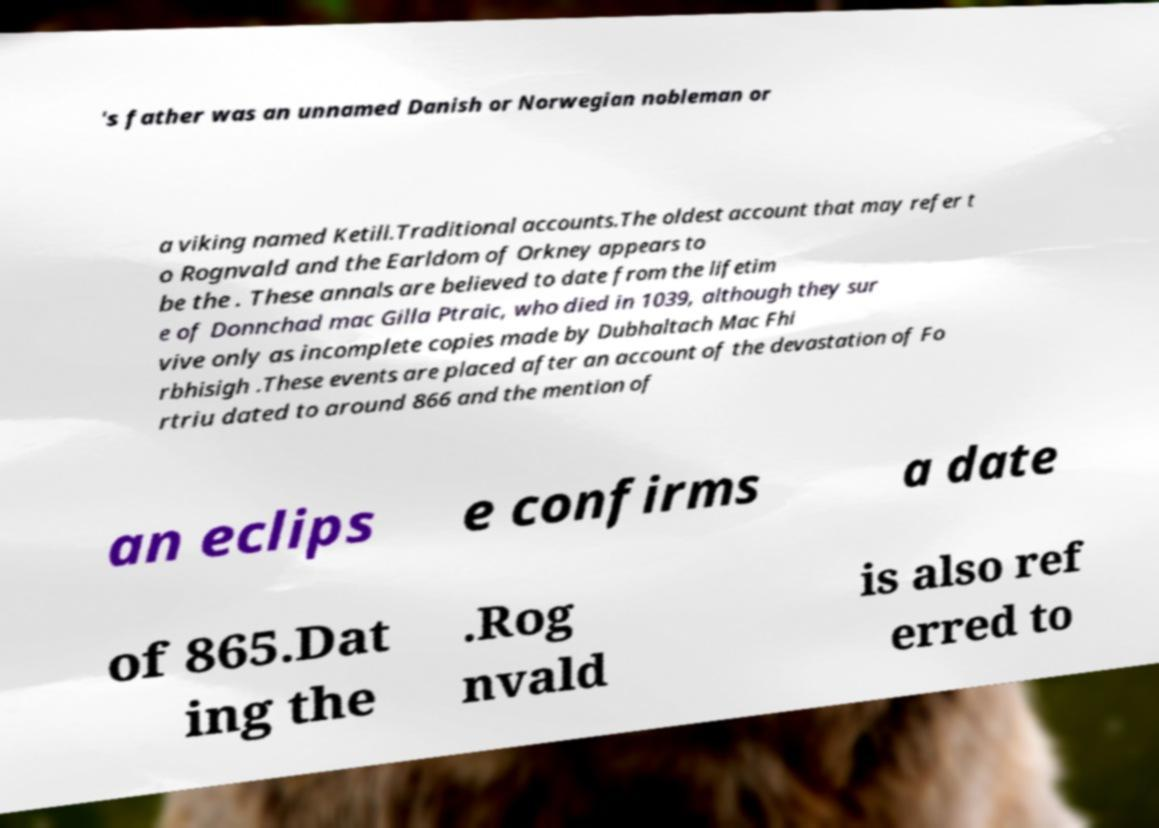Please identify and transcribe the text found in this image. 's father was an unnamed Danish or Norwegian nobleman or a viking named Ketill.Traditional accounts.The oldest account that may refer t o Rognvald and the Earldom of Orkney appears to be the . These annals are believed to date from the lifetim e of Donnchad mac Gilla Ptraic, who died in 1039, although they sur vive only as incomplete copies made by Dubhaltach Mac Fhi rbhisigh .These events are placed after an account of the devastation of Fo rtriu dated to around 866 and the mention of an eclips e confirms a date of 865.Dat ing the .Rog nvald is also ref erred to 